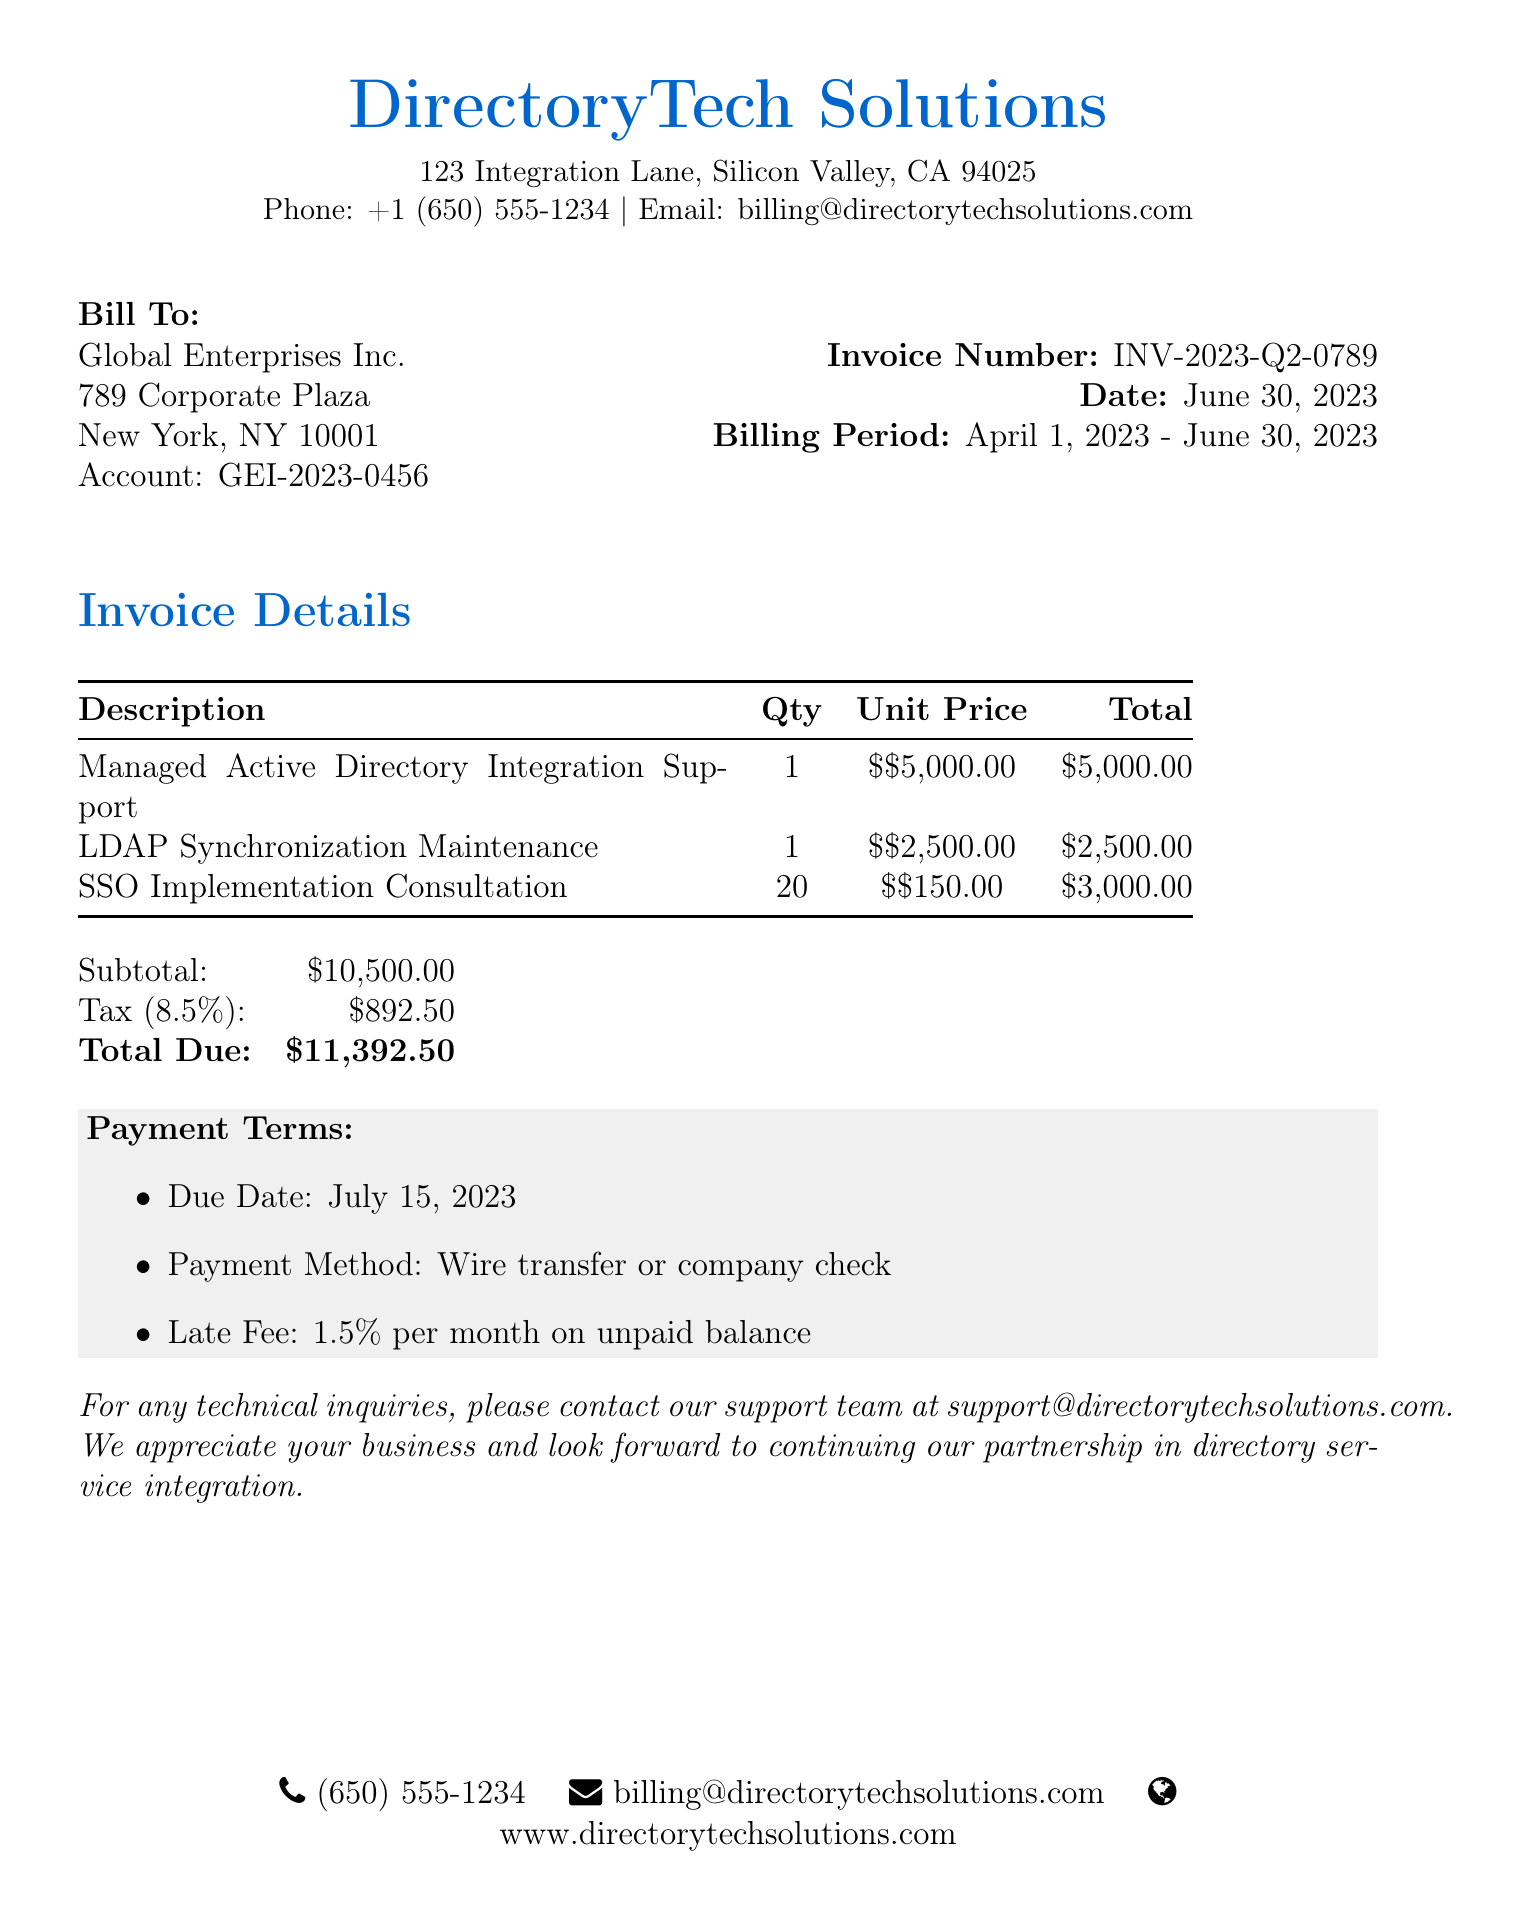What is the invoice number? The invoice number is specified in the document as a key identifier for billing purposes.
Answer: INV-2023-Q2-0789 What is the billing period? The billing period indicates the timeframe for which services were billed, detailing start and end dates.
Answer: April 1, 2023 - June 30, 2023 What is the subtotal amount? The subtotal is the sum of all billed services before tax, reflecting the core charges for services rendered.
Answer: $10,500.00 What is the tax rate applied? The tax rate is detailed as part of the billing calculations, showing applicable charges based on services rendered.
Answer: 8.5% What is the total due amount? The total due indicates the full amount that must be paid including taxes and service fees.
Answer: $11,392.50 How many SSO Implementation Consultation hours were billed? The quantity reflects the number of service hours billed for consultation and is a key factor in total charges.
Answer: 20 When is the payment due date? The due date outlines when the payment for the invoice must be completed to avoid late fees.
Answer: July 15, 2023 What is the late fee percentage? The late fee percentage specifies the cost incurred for late payments and is critical for compliance with payment terms.
Answer: 1.5% per month 